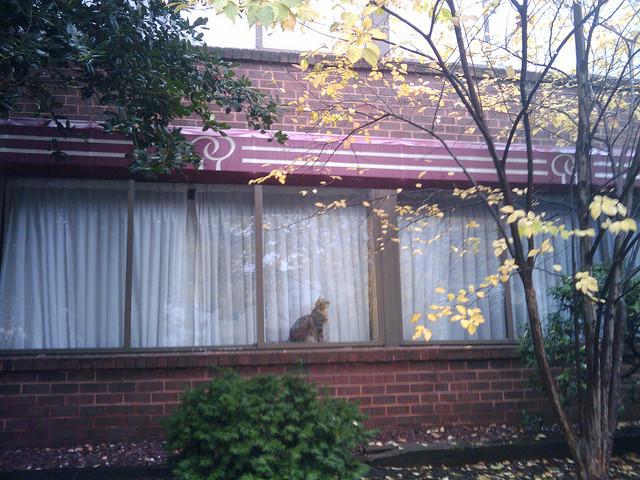What time is it?
Concise answer only. Daytime. Could it be early autumn?
Short answer required. Yes. What is sitting inside the window?
Concise answer only. Cat. 